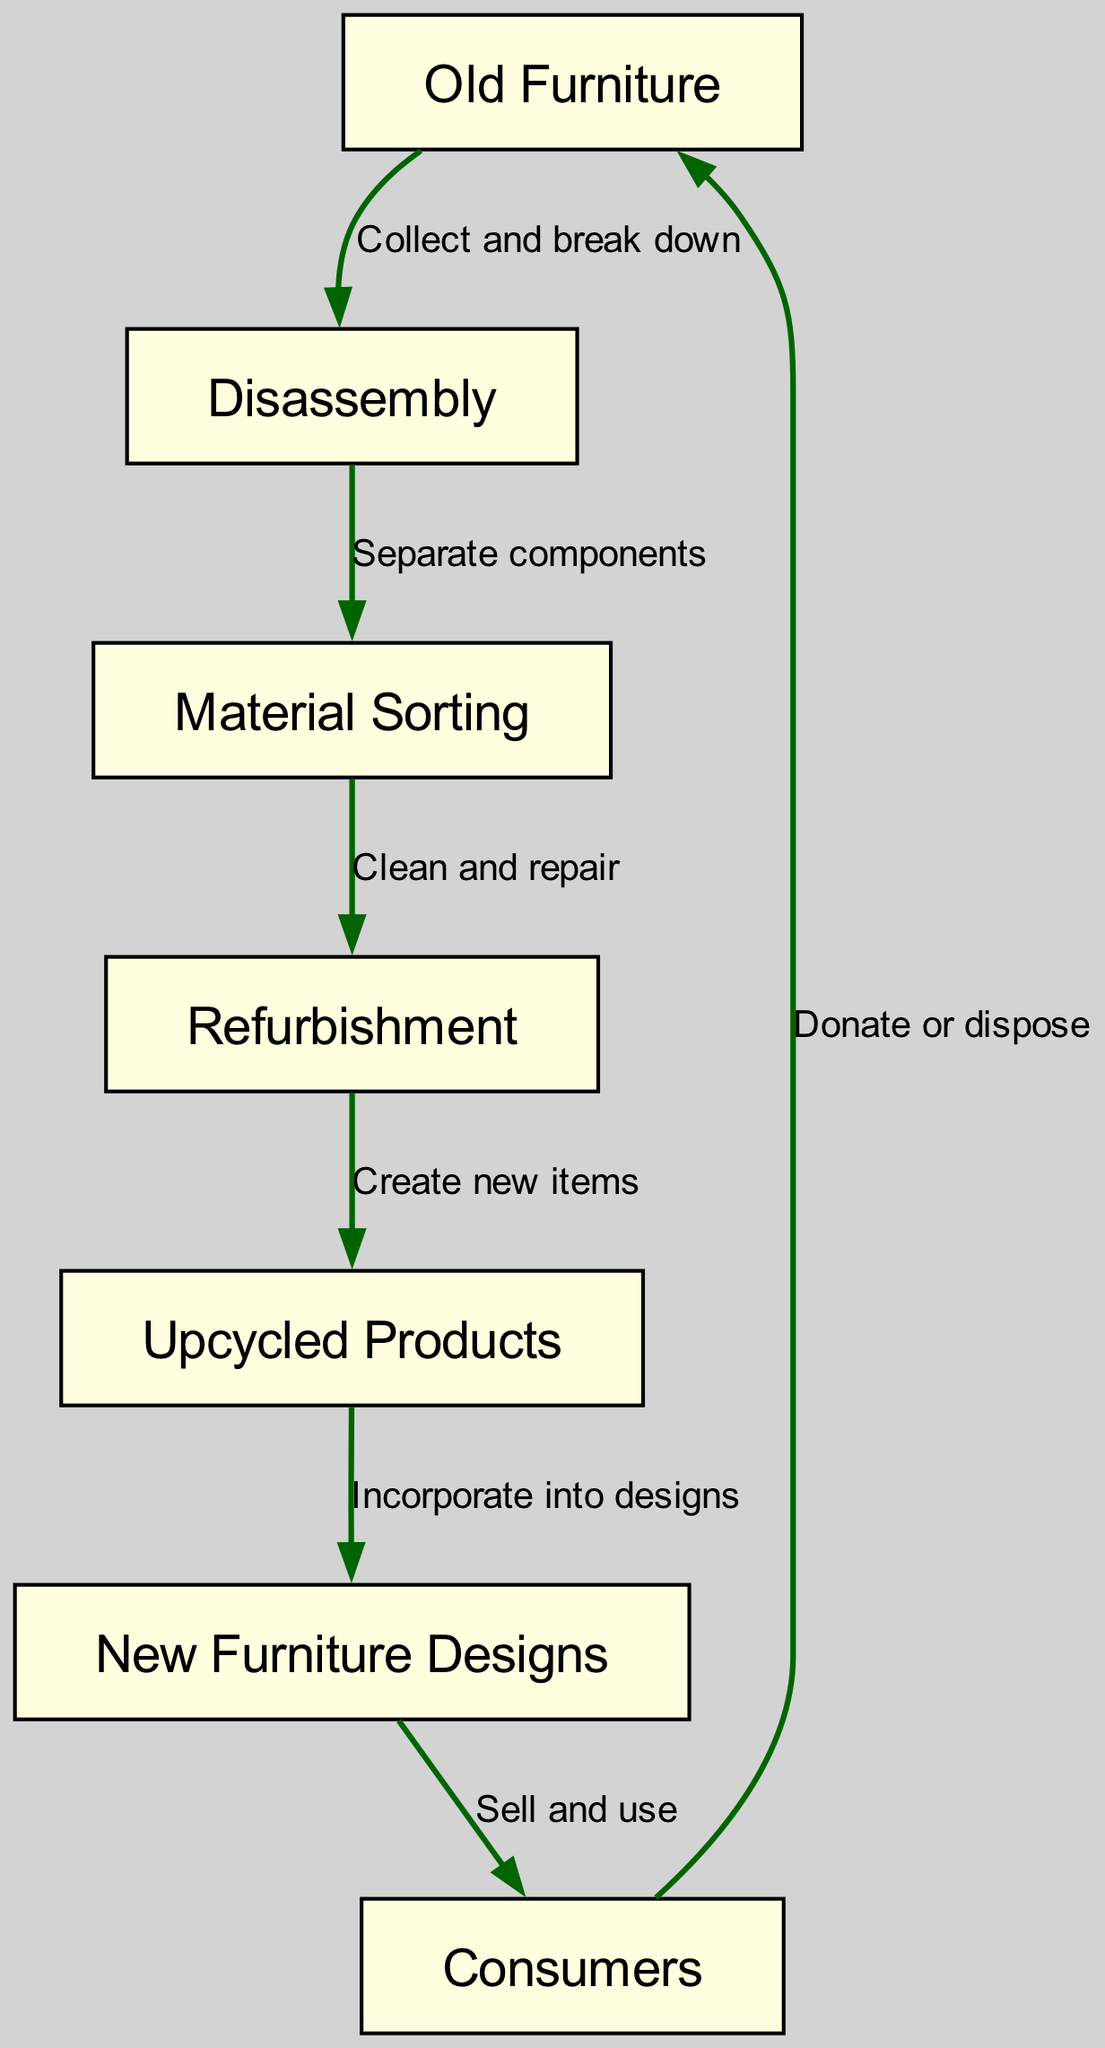What is the first step in the recycling process? The diagram indicates that the first step is "Disassembly," which follows the "Old Furniture" node. After collecting the old furniture, it is broken down for further processing.
Answer: Disassembly How many nodes are there in the diagram? To determine the number of nodes, we can count the unique items listed in the "nodes" section. There are a total of six distinct steps in the recycling process.
Answer: 6 What follows "Material Sorting" in the flow? The edge leading from "Material Sorting" indicates that the next step is "Refurbishment." This shows the direct connection between sorting the materials and the subsequent process of repairing them.
Answer: Refurbishment What is created after "Refurbishment"? The diagram shows that after the "Refurbishment" step, "Upcycled Products" are created. This demonstrates the result of repairing and cleaning the materials.
Answer: Upcycled Products What action takes place between "Upcycled Products" and "New Furniture Designs"? The connection in the diagram specifies that the action between these two nodes is "Incorporate into designs." This indicates that upcycled products are integrated into new furniture concepts.
Answer: Incorporate into designs How do consumers contribute back to the process? According to the diagram, consumers contribute back to the process by either donating or disposing of their old furniture, thus feeding the cycle of recycling.
Answer: Donate or dispose Which node has the most connections according to the diagram? The diagram shows that "Old Furniture" has a connection to "Disassembly," and it's part of the return flow from "Consumers." On analyzing the edges, it's clear that "Consumers" have engagements both in selling and the donation/disposal process.
Answer: Consumers What is the last step in the recycling process? The flow of the diagram reveals that the last step is "Consumers," which indicates the end point of the recycling and upcycling process, where the new designs are sold and used.
Answer: Consumers 